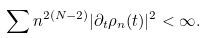Convert formula to latex. <formula><loc_0><loc_0><loc_500><loc_500>\sum n ^ { 2 ( N - 2 ) } | \partial _ { t } \rho _ { n } ( t ) | ^ { 2 } < \infty .</formula> 